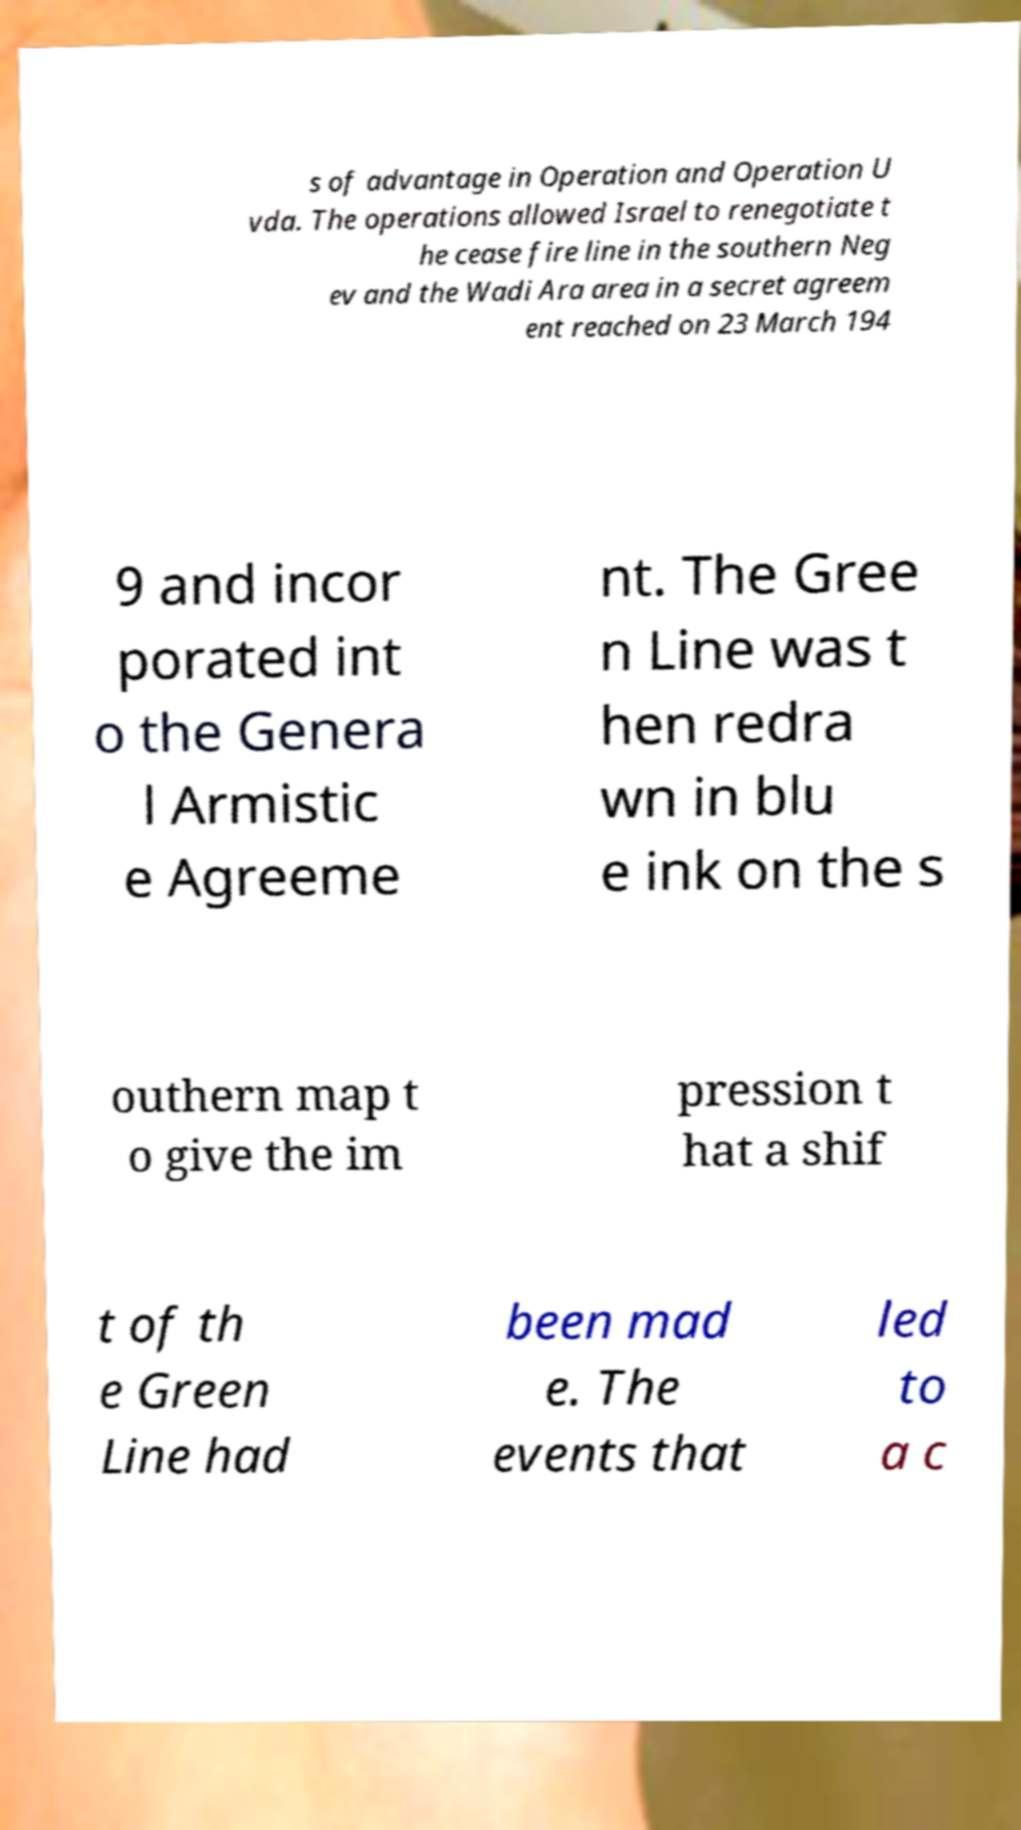Could you assist in decoding the text presented in this image and type it out clearly? s of advantage in Operation and Operation U vda. The operations allowed Israel to renegotiate t he cease fire line in the southern Neg ev and the Wadi Ara area in a secret agreem ent reached on 23 March 194 9 and incor porated int o the Genera l Armistic e Agreeme nt. The Gree n Line was t hen redra wn in blu e ink on the s outhern map t o give the im pression t hat a shif t of th e Green Line had been mad e. The events that led to a c 